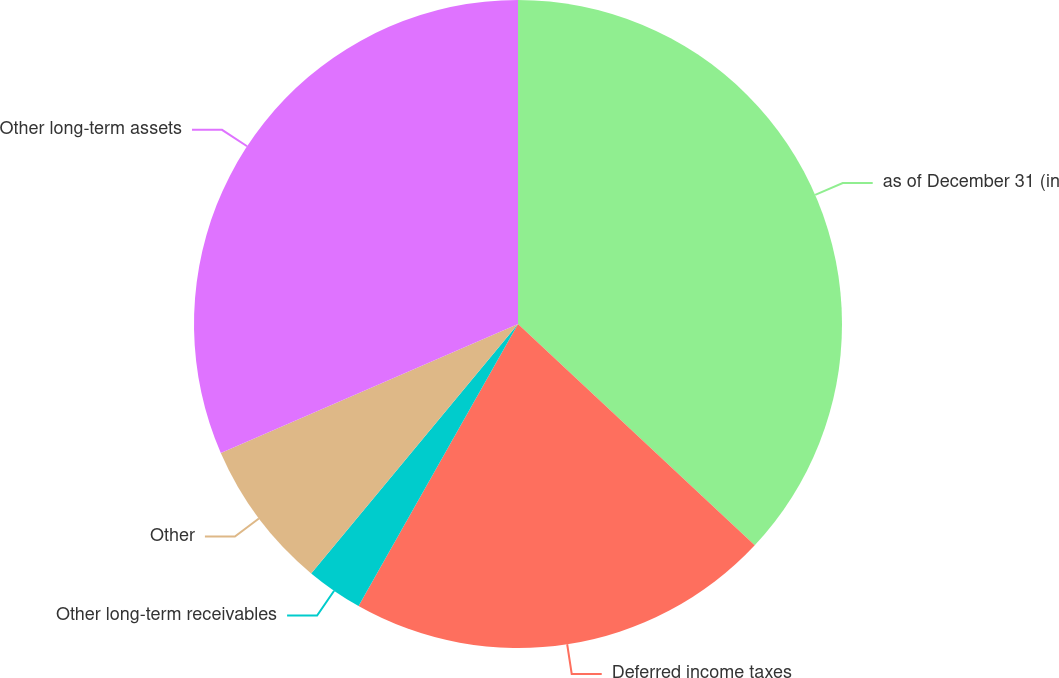Convert chart to OTSL. <chart><loc_0><loc_0><loc_500><loc_500><pie_chart><fcel>as of December 31 (in<fcel>Deferred income taxes<fcel>Other long-term receivables<fcel>Other<fcel>Other long-term assets<nl><fcel>36.96%<fcel>21.23%<fcel>2.83%<fcel>7.46%<fcel>31.52%<nl></chart> 